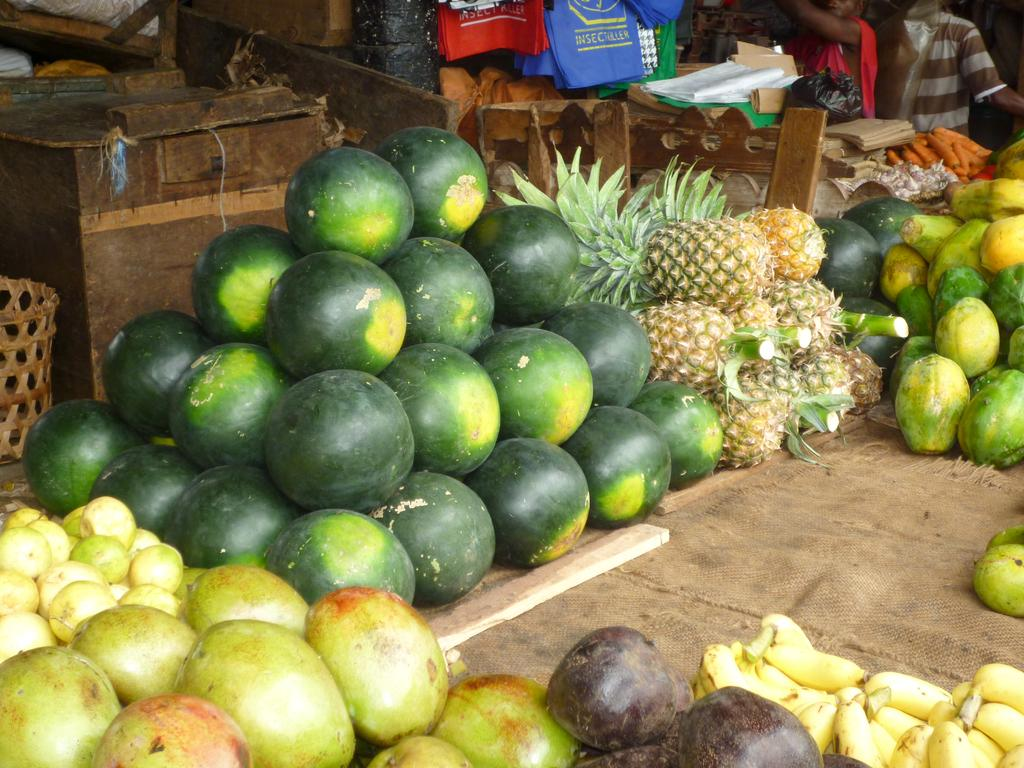What types of fruits are present in the image? There are watermelons, pineapples, papaya, and a carrot in the image. What other items can be seen in the image besides fruits? There are t-shirts in the image. Are there any people visible in the image? Yes, there are two people in the background of the image. What can be seen behind the fruits in the image? There are wooden objects behind the fruits in the image. What arithmetic problem can be solved using the fruits in the image? There is no arithmetic problem present in the image, as it features fruits and other objects. What type of harmony can be observed between the fruits and the wooden objects in the image? There is no harmony between the fruits and the wooden objects in the image, as they are separate entities. 